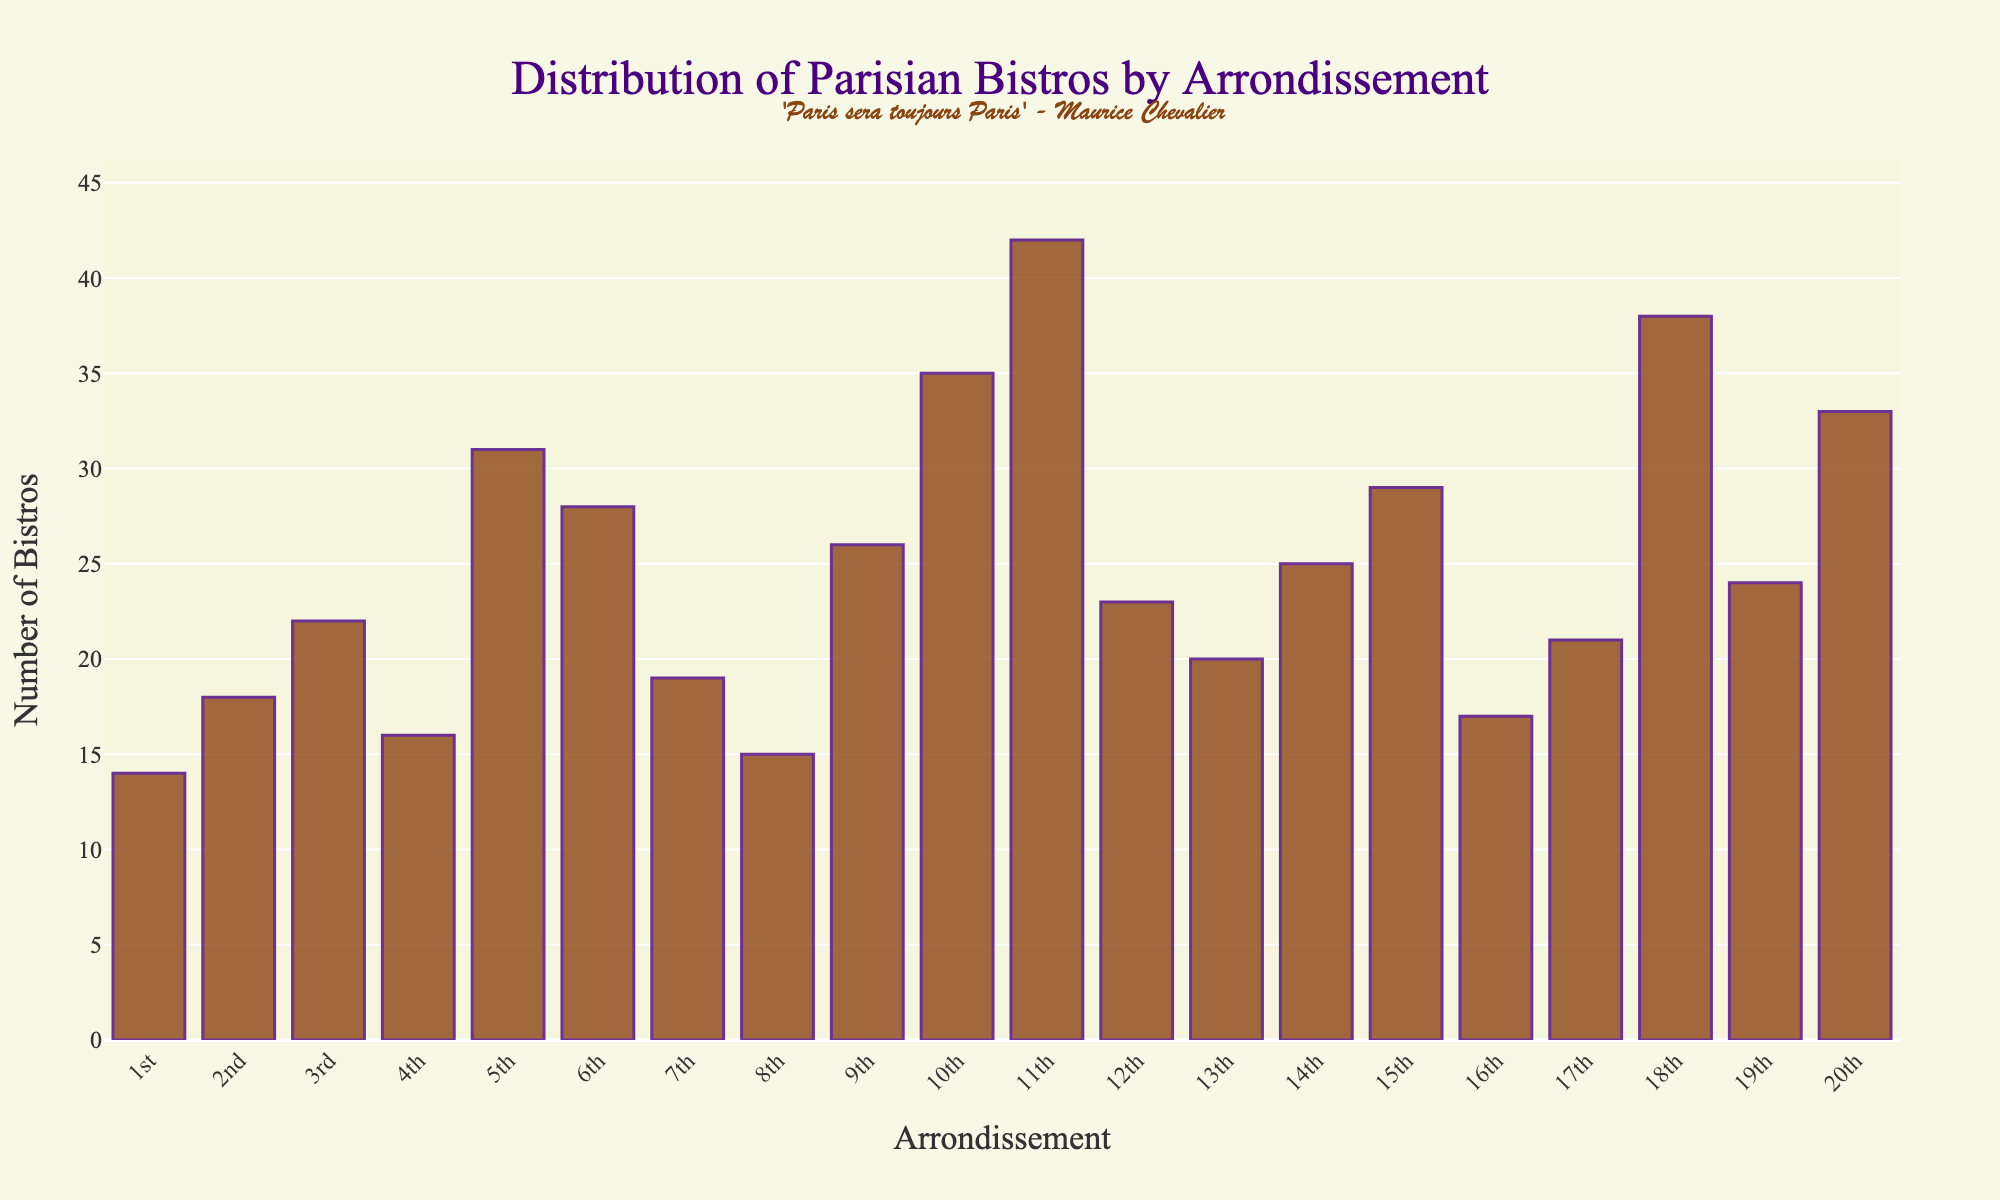Which arrondissement has the highest number of bistros? By looking at the height of the bars, the 11th arrondissement has the tallest bar, indicating the highest number of bistros.
Answer: 11th Which arrondissement has fewer bistros, the 1st or the 7th? By comparing the heights of the bars for the 1st and 7th arrondissements, the bar for the 1st arrondissement is shorter.
Answer: 1st What is the total number of bistros in the 9th, 10th, and 11th arrondissements? Summing up the numbers from the bars for the 9th, 10th, and 11th arrondissements: 26 + 35 + 42 = 103
Answer: 103 How many more bistros are there in the 5th arrondissement compared to the 8th arrondissement? Finding the difference between the bars for the 5th and 8th arrondissements: 31 - 15 = 16
Answer: 16 What is the average number of bistros across all arrondissements? Summing all the bistros from each arrondissement and dividing by the total number of arrondissements: (14 + 18 + 22 + 16 + 31 + 28 + 19 + 15 + 26 + 35 + 42 + 23 + 20 + 25 + 29 + 17 + 21 + 38 + 24 + 33) / 20 = 24.85
Answer: 24.85 Which arrondissement has a lower number of bistros, the 4th or the 15th? Comparing the heights of the bars, the 4th arrondissement's bar is shorter than the 15th's.
Answer: 4th How many arrondissements have more than 30 bistros? Identifying the arrondissements with bars that exceed the 30-mark: 5th, 10th, 11th, 18th, and 20th. So, there are 5 such arrondissements.
Answer: 5 What is the difference in the number of bistros between the arrondissement with the fewest bistros and the arrondissement with the most bistros? Finding the numbers from the bars: the 1st arrondissement has the fewest with 14, and the 11th has the most with 42. Therefore, the difference is 42 - 14 = 28
Answer: 28 Which arrondissements have more than 25 bistros but fewer than 35 bistros? Identifying bars that fall within the range of greater than 25 but fewer than 35: 9th, 14th, 15th, 16th, 17th, and 19th.
Answer: 9th, 14th, 15th, 17th, 19th If someone wants to visit three arrondissements with the least number of bistros, which ones should they choose? By identifying the shortest bars representing the fewest bistros: the 1st (14), the 4th (16), and the 16th (17).
Answer: 1st, 4th, 16th 